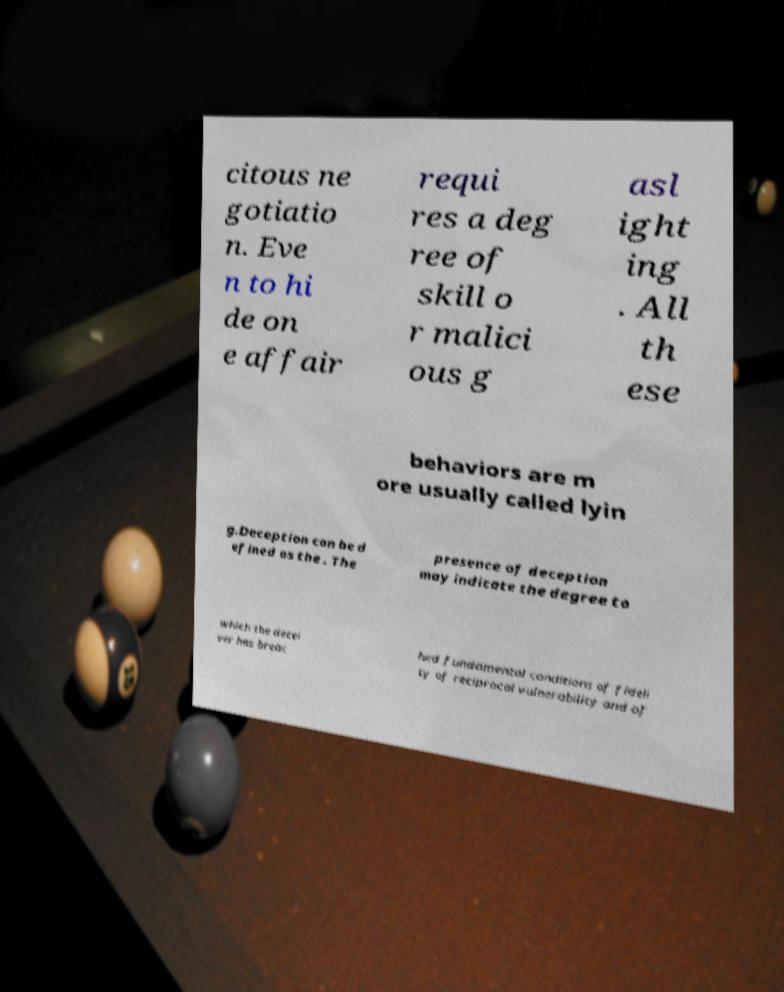I need the written content from this picture converted into text. Can you do that? citous ne gotiatio n. Eve n to hi de on e affair requi res a deg ree of skill o r malici ous g asl ight ing . All th ese behaviors are m ore usually called lyin g.Deception can be d efined as the . The presence of deception may indicate the degree to which the decei ver has breac hed fundamental conditions of fideli ty of reciprocal vulnerability and of 